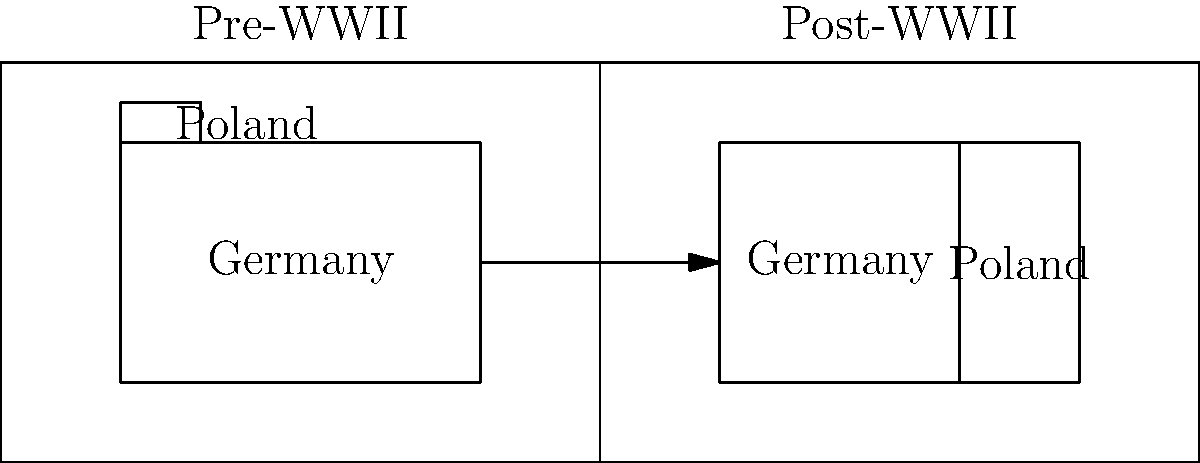Based on the maps showing Europe before and after World War II, what significant territorial change occurred between Germany and Poland? To answer this question, we need to analyze the two maps carefully:

1. Pre-WWII Map (left):
   - Germany is shown as a large territory.
   - Poland is depicted as a small area to the east of Germany.

2. Post-WWII Map (right):
   - Germany's territory is noticeably smaller.
   - Poland's territory is significantly larger and extends westward.

3. Comparing the two maps:
   - We can see that Germany's eastern border has moved westward.
   - Poland's western border has expanded considerably.

4. Historical context:
   - After WWII, the Allies decided to shift Poland's borders westward.
   - This was partly to compensate Poland for territories lost to the Soviet Union in the east.
   - The newly acquired western territories for Poland came at the expense of Germany.

5. Conclusion:
   - The significant territorial change was that Poland gained considerable territory from Germany in the west.
Answer: Poland gained significant territory from Germany in the west. 